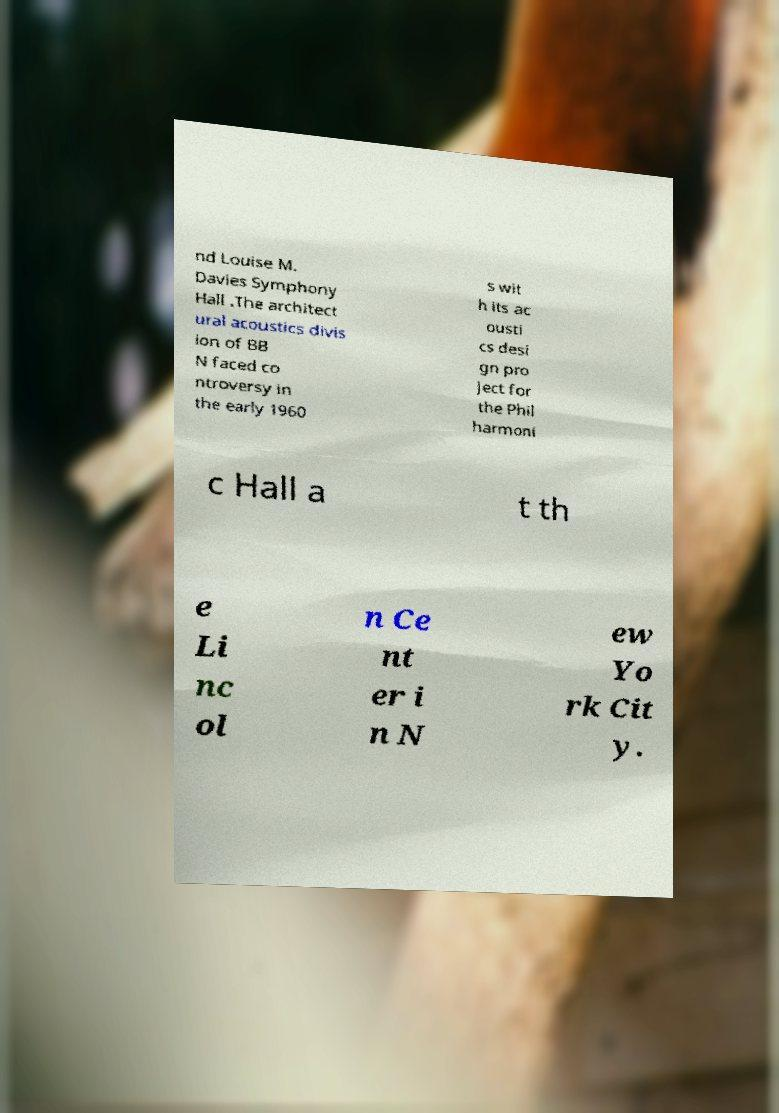Can you accurately transcribe the text from the provided image for me? nd Louise M. Davies Symphony Hall .The architect ural acoustics divis ion of BB N faced co ntroversy in the early 1960 s wit h its ac ousti cs desi gn pro ject for the Phil harmoni c Hall a t th e Li nc ol n Ce nt er i n N ew Yo rk Cit y. 